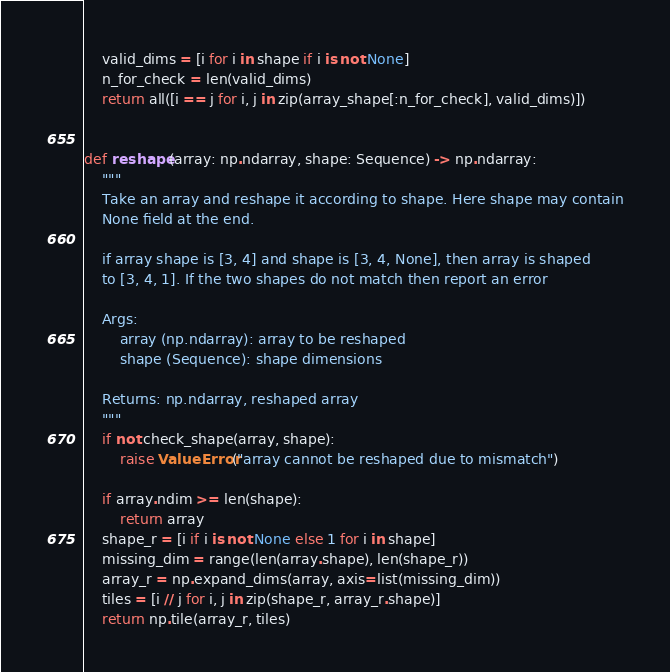Convert code to text. <code><loc_0><loc_0><loc_500><loc_500><_Python_>    valid_dims = [i for i in shape if i is not None]
    n_for_check = len(valid_dims)
    return all([i == j for i, j in zip(array_shape[:n_for_check], valid_dims)])


def reshape(array: np.ndarray, shape: Sequence) -> np.ndarray:
    """
    Take an array and reshape it according to shape. Here shape may contain
    None field at the end.

    if array shape is [3, 4] and shape is [3, 4, None], then array is shaped
    to [3, 4, 1]. If the two shapes do not match then report an error

    Args:
        array (np.ndarray): array to be reshaped
        shape (Sequence): shape dimensions

    Returns: np.ndarray, reshaped array
    """
    if not check_shape(array, shape):
        raise ValueError("array cannot be reshaped due to mismatch")

    if array.ndim >= len(shape):
        return array
    shape_r = [i if i is not None else 1 for i in shape]
    missing_dim = range(len(array.shape), len(shape_r))
    array_r = np.expand_dims(array, axis=list(missing_dim))
    tiles = [i // j for i, j in zip(shape_r, array_r.shape)]
    return np.tile(array_r, tiles)
</code> 